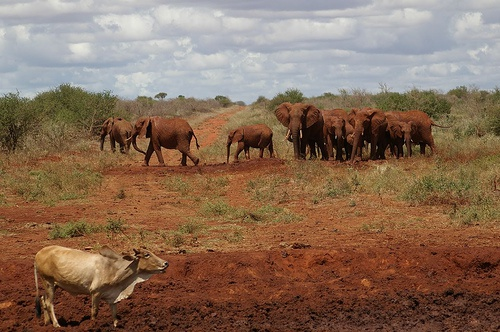Describe the objects in this image and their specific colors. I can see cow in darkgray, maroon, tan, and gray tones, elephant in darkgray, maroon, black, brown, and gray tones, elephant in darkgray, black, maroon, and brown tones, elephant in darkgray, black, maroon, and brown tones, and elephant in darkgray, maroon, black, and brown tones in this image. 